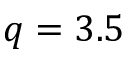Convert formula to latex. <formula><loc_0><loc_0><loc_500><loc_500>q = 3 . 5</formula> 